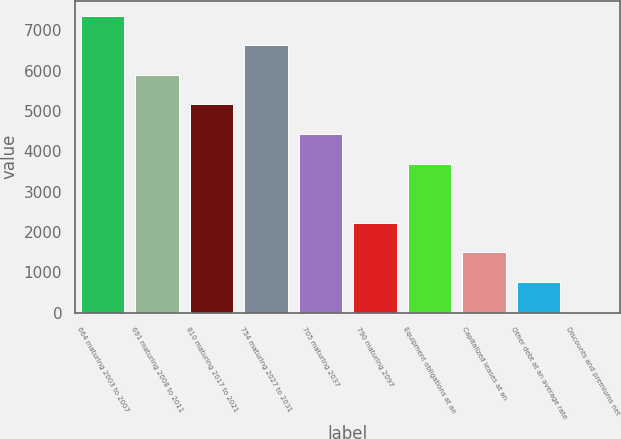<chart> <loc_0><loc_0><loc_500><loc_500><bar_chart><fcel>664 maturing 2003 to 2007<fcel>691 maturing 2008 to 2011<fcel>810 maturing 2017 to 2021<fcel>754 maturing 2027 to 2031<fcel>705 maturing 2037<fcel>790 maturing 2097<fcel>Equipment obligations at an<fcel>Capitalized leases at an<fcel>Other debt at an average rate<fcel>Discounts and premiums net<nl><fcel>7364<fcel>5897<fcel>5163.5<fcel>6630.5<fcel>4430<fcel>2229.5<fcel>3696.5<fcel>1496<fcel>762.5<fcel>29<nl></chart> 